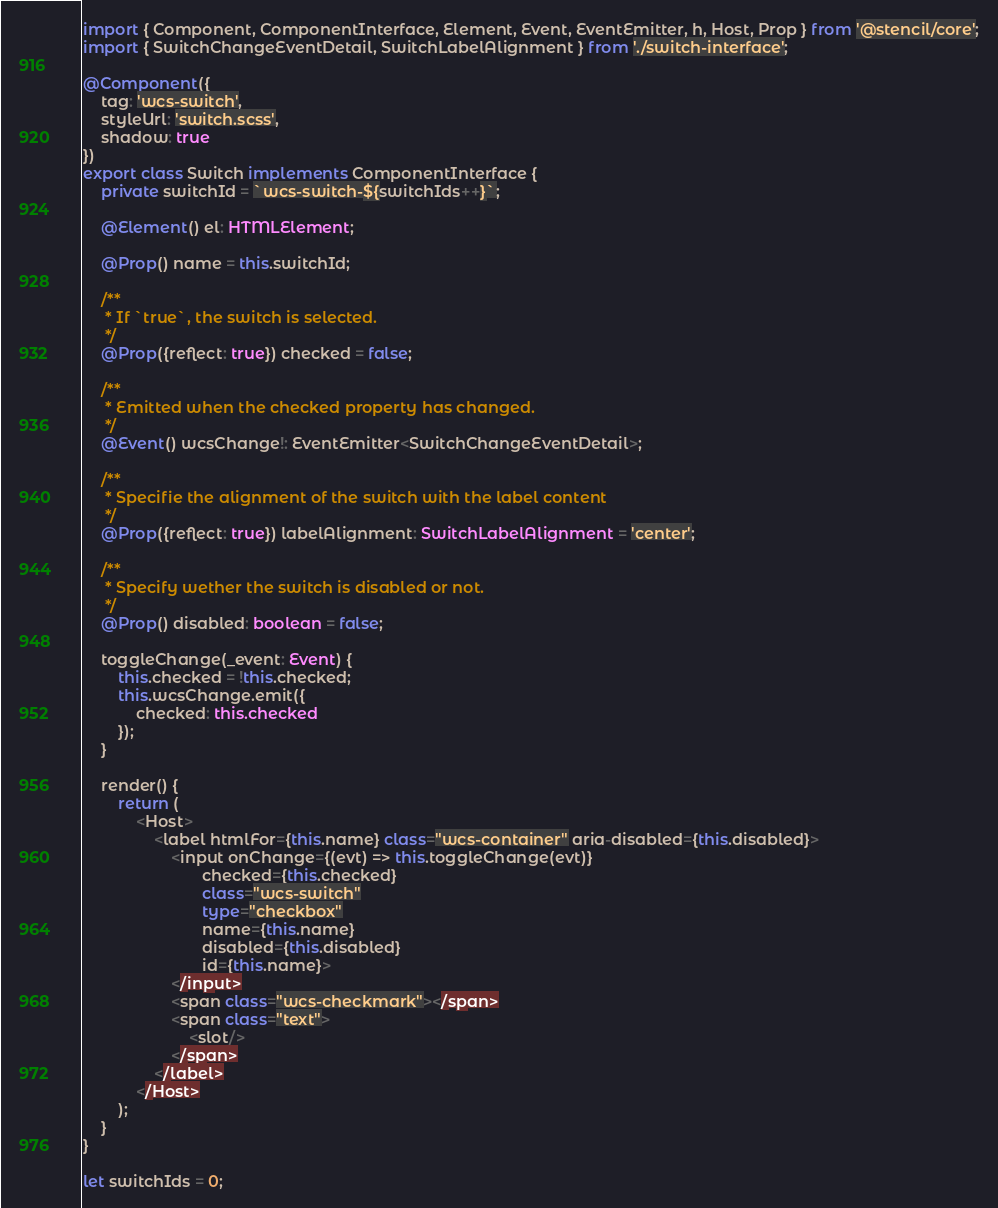Convert code to text. <code><loc_0><loc_0><loc_500><loc_500><_TypeScript_>import { Component, ComponentInterface, Element, Event, EventEmitter, h, Host, Prop } from '@stencil/core';
import { SwitchChangeEventDetail, SwitchLabelAlignment } from './switch-interface';

@Component({
    tag: 'wcs-switch',
    styleUrl: 'switch.scss',
    shadow: true
})
export class Switch implements ComponentInterface {
    private switchId = `wcs-switch-${switchIds++}`;

    @Element() el: HTMLElement;

    @Prop() name = this.switchId;

    /**
     * If `true`, the switch is selected.
     */
    @Prop({reflect: true}) checked = false;

    /**
     * Emitted when the checked property has changed.
     */
    @Event() wcsChange!: EventEmitter<SwitchChangeEventDetail>;

    /**
     * Specifie the alignment of the switch with the label content
     */
    @Prop({reflect: true}) labelAlignment: SwitchLabelAlignment = 'center';

    /**
     * Specify wether the switch is disabled or not.
     */
    @Prop() disabled: boolean = false;

    toggleChange(_event: Event) {
        this.checked = !this.checked;
        this.wcsChange.emit({
            checked: this.checked
        });
    }

    render() {
        return (
            <Host>
                <label htmlFor={this.name} class="wcs-container" aria-disabled={this.disabled}>
                    <input onChange={(evt) => this.toggleChange(evt)}
                           checked={this.checked}
                           class="wcs-switch"
                           type="checkbox"
                           name={this.name}
                           disabled={this.disabled}
                           id={this.name}>
                    </input>
                    <span class="wcs-checkmark"></span>
                    <span class="text">
                        <slot/>
                    </span>
                </label>
            </Host>
        );
    }
}

let switchIds = 0;
</code> 